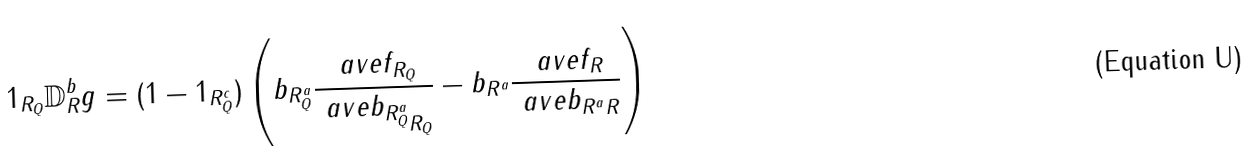Convert formula to latex. <formula><loc_0><loc_0><loc_500><loc_500>1 _ { R _ { Q } } \mathbb { D } _ { R } ^ { b } g = ( 1 - 1 _ { R _ { Q } ^ { c } } ) \left ( b _ { R _ { Q } ^ { a } } \frac { \ a v e { f } _ { R _ { Q } } } { \ a v e { b _ { R _ { Q } ^ { a } } } _ { R _ { Q } } } - b _ { R ^ { a } } \frac { \ a v e { f } _ { R } } { \ a v e { b _ { R ^ { a } } } _ { R } } \right )</formula> 